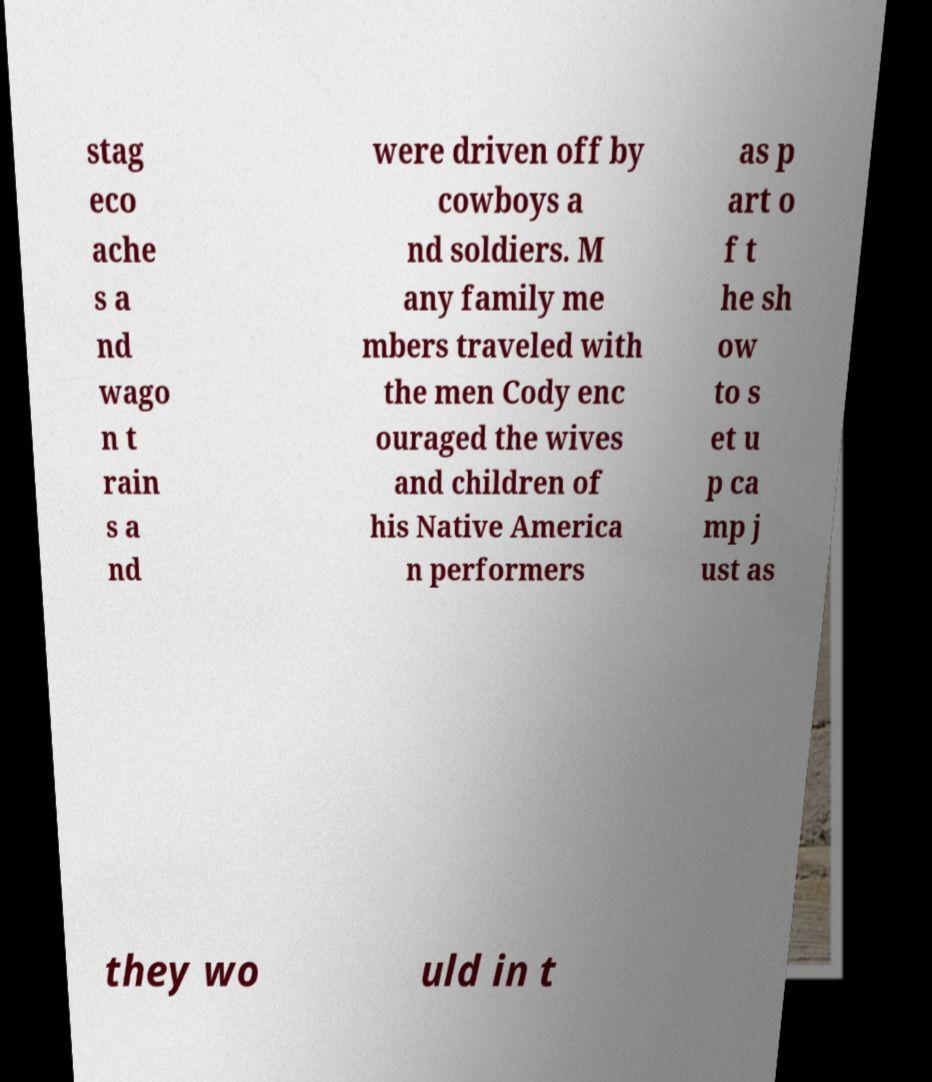Please read and relay the text visible in this image. What does it say? stag eco ache s a nd wago n t rain s a nd were driven off by cowboys a nd soldiers. M any family me mbers traveled with the men Cody enc ouraged the wives and children of his Native America n performers as p art o f t he sh ow to s et u p ca mp j ust as they wo uld in t 